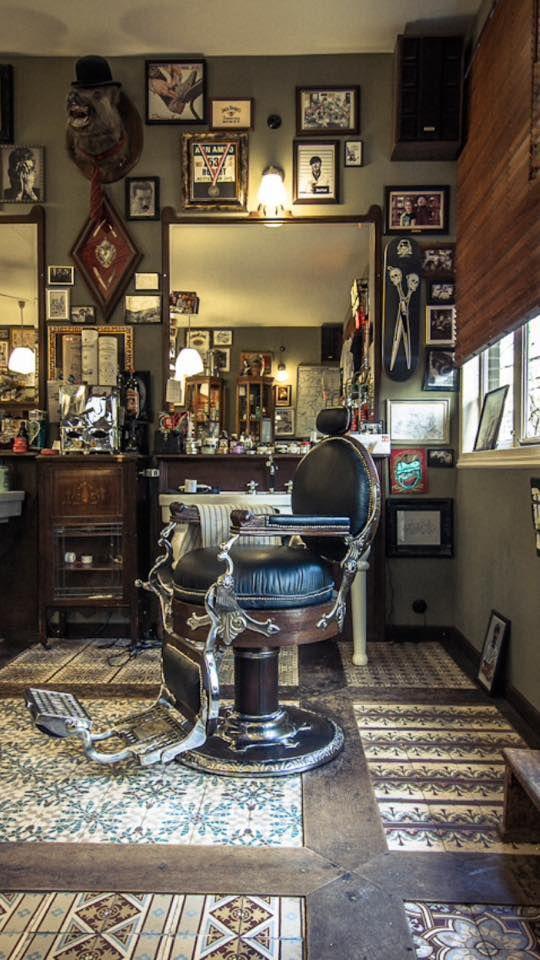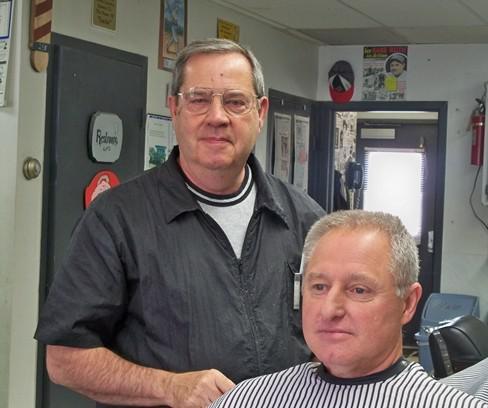The first image is the image on the left, the second image is the image on the right. Assess this claim about the two images: "The left and right image contains a total of four men in a barber shop.". Correct or not? Answer yes or no. No. The first image is the image on the left, the second image is the image on the right. Evaluate the accuracy of this statement regarding the images: "Exactly two men in the barber shop are clean shaven.". Is it true? Answer yes or no. Yes. 